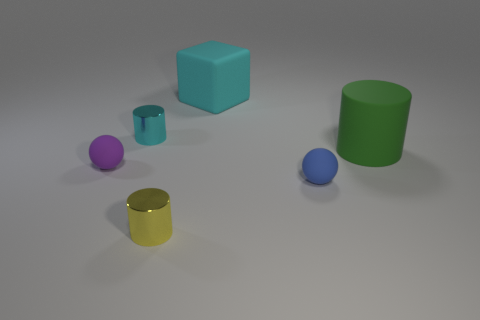Add 1 tiny yellow cylinders. How many objects exist? 7 Subtract all balls. How many objects are left? 4 Add 1 big rubber blocks. How many big rubber blocks are left? 2 Add 6 big gray rubber cylinders. How many big gray rubber cylinders exist? 6 Subtract 0 gray cubes. How many objects are left? 6 Subtract all small yellow cylinders. Subtract all yellow metallic cylinders. How many objects are left? 4 